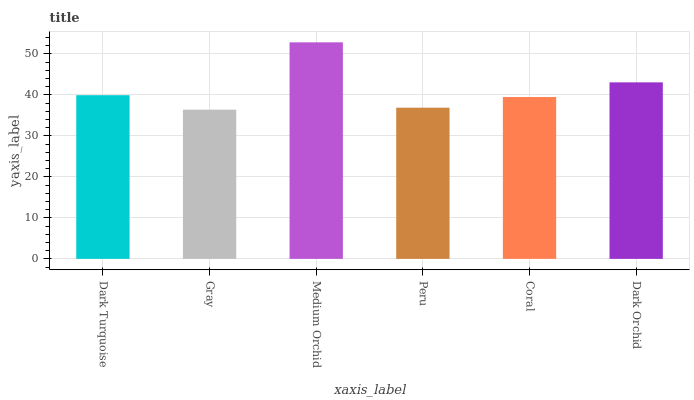Is Gray the minimum?
Answer yes or no. Yes. Is Medium Orchid the maximum?
Answer yes or no. Yes. Is Medium Orchid the minimum?
Answer yes or no. No. Is Gray the maximum?
Answer yes or no. No. Is Medium Orchid greater than Gray?
Answer yes or no. Yes. Is Gray less than Medium Orchid?
Answer yes or no. Yes. Is Gray greater than Medium Orchid?
Answer yes or no. No. Is Medium Orchid less than Gray?
Answer yes or no. No. Is Dark Turquoise the high median?
Answer yes or no. Yes. Is Coral the low median?
Answer yes or no. Yes. Is Dark Orchid the high median?
Answer yes or no. No. Is Dark Orchid the low median?
Answer yes or no. No. 